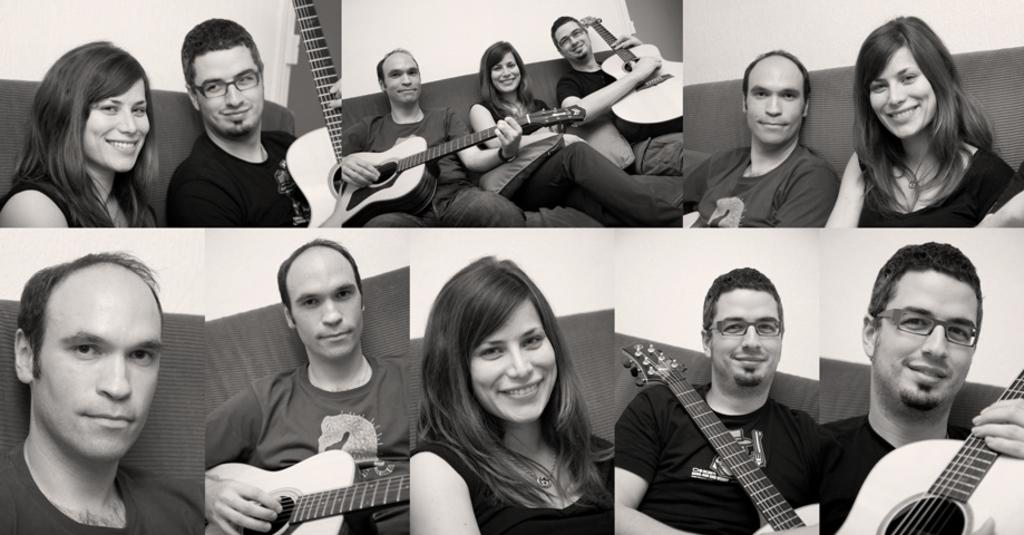What type of location is depicted in the image? The image is of a college. Can you describe the people in the image? There is a woman and two men in the picture. What are the two men holding in their hands? The two men are holding guitars in their hands. Where is the calendar located in the image? There is no calendar present in the image. What type of tin can be seen in the image? There is no tin present in the image. 